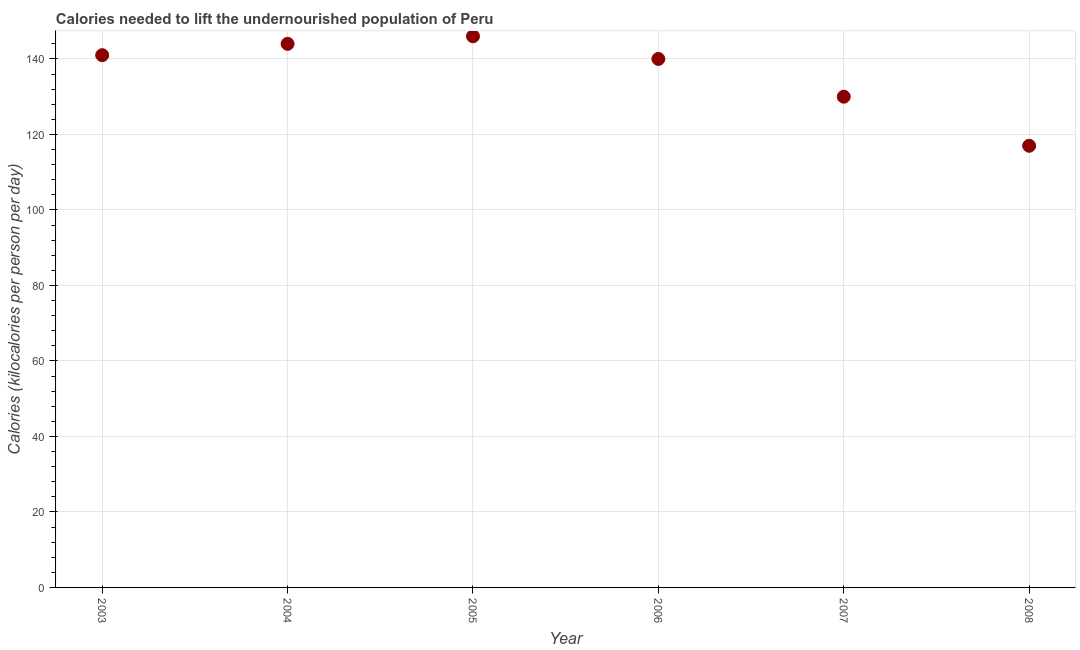What is the depth of food deficit in 2008?
Ensure brevity in your answer.  117. Across all years, what is the maximum depth of food deficit?
Offer a very short reply. 146. Across all years, what is the minimum depth of food deficit?
Your answer should be compact. 117. In which year was the depth of food deficit minimum?
Your answer should be very brief. 2008. What is the sum of the depth of food deficit?
Your answer should be compact. 818. What is the difference between the depth of food deficit in 2005 and 2008?
Give a very brief answer. 29. What is the average depth of food deficit per year?
Keep it short and to the point. 136.33. What is the median depth of food deficit?
Offer a very short reply. 140.5. What is the ratio of the depth of food deficit in 2004 to that in 2006?
Your answer should be very brief. 1.03. Is the difference between the depth of food deficit in 2003 and 2008 greater than the difference between any two years?
Keep it short and to the point. No. Is the sum of the depth of food deficit in 2006 and 2008 greater than the maximum depth of food deficit across all years?
Offer a very short reply. Yes. What is the difference between the highest and the lowest depth of food deficit?
Your answer should be very brief. 29. What is the title of the graph?
Ensure brevity in your answer.  Calories needed to lift the undernourished population of Peru. What is the label or title of the X-axis?
Make the answer very short. Year. What is the label or title of the Y-axis?
Your answer should be very brief. Calories (kilocalories per person per day). What is the Calories (kilocalories per person per day) in 2003?
Your answer should be very brief. 141. What is the Calories (kilocalories per person per day) in 2004?
Your answer should be compact. 144. What is the Calories (kilocalories per person per day) in 2005?
Ensure brevity in your answer.  146. What is the Calories (kilocalories per person per day) in 2006?
Give a very brief answer. 140. What is the Calories (kilocalories per person per day) in 2007?
Keep it short and to the point. 130. What is the Calories (kilocalories per person per day) in 2008?
Your answer should be very brief. 117. What is the difference between the Calories (kilocalories per person per day) in 2003 and 2004?
Make the answer very short. -3. What is the difference between the Calories (kilocalories per person per day) in 2003 and 2005?
Your answer should be compact. -5. What is the difference between the Calories (kilocalories per person per day) in 2003 and 2006?
Offer a terse response. 1. What is the difference between the Calories (kilocalories per person per day) in 2003 and 2007?
Your answer should be very brief. 11. What is the difference between the Calories (kilocalories per person per day) in 2004 and 2006?
Offer a very short reply. 4. What is the difference between the Calories (kilocalories per person per day) in 2004 and 2007?
Ensure brevity in your answer.  14. What is the difference between the Calories (kilocalories per person per day) in 2005 and 2007?
Provide a succinct answer. 16. What is the difference between the Calories (kilocalories per person per day) in 2005 and 2008?
Make the answer very short. 29. What is the difference between the Calories (kilocalories per person per day) in 2006 and 2007?
Provide a succinct answer. 10. What is the difference between the Calories (kilocalories per person per day) in 2006 and 2008?
Make the answer very short. 23. What is the ratio of the Calories (kilocalories per person per day) in 2003 to that in 2006?
Your response must be concise. 1.01. What is the ratio of the Calories (kilocalories per person per day) in 2003 to that in 2007?
Make the answer very short. 1.08. What is the ratio of the Calories (kilocalories per person per day) in 2003 to that in 2008?
Your answer should be very brief. 1.21. What is the ratio of the Calories (kilocalories per person per day) in 2004 to that in 2005?
Make the answer very short. 0.99. What is the ratio of the Calories (kilocalories per person per day) in 2004 to that in 2006?
Your answer should be compact. 1.03. What is the ratio of the Calories (kilocalories per person per day) in 2004 to that in 2007?
Give a very brief answer. 1.11. What is the ratio of the Calories (kilocalories per person per day) in 2004 to that in 2008?
Your answer should be compact. 1.23. What is the ratio of the Calories (kilocalories per person per day) in 2005 to that in 2006?
Keep it short and to the point. 1.04. What is the ratio of the Calories (kilocalories per person per day) in 2005 to that in 2007?
Your answer should be very brief. 1.12. What is the ratio of the Calories (kilocalories per person per day) in 2005 to that in 2008?
Keep it short and to the point. 1.25. What is the ratio of the Calories (kilocalories per person per day) in 2006 to that in 2007?
Provide a short and direct response. 1.08. What is the ratio of the Calories (kilocalories per person per day) in 2006 to that in 2008?
Your answer should be very brief. 1.2. What is the ratio of the Calories (kilocalories per person per day) in 2007 to that in 2008?
Make the answer very short. 1.11. 